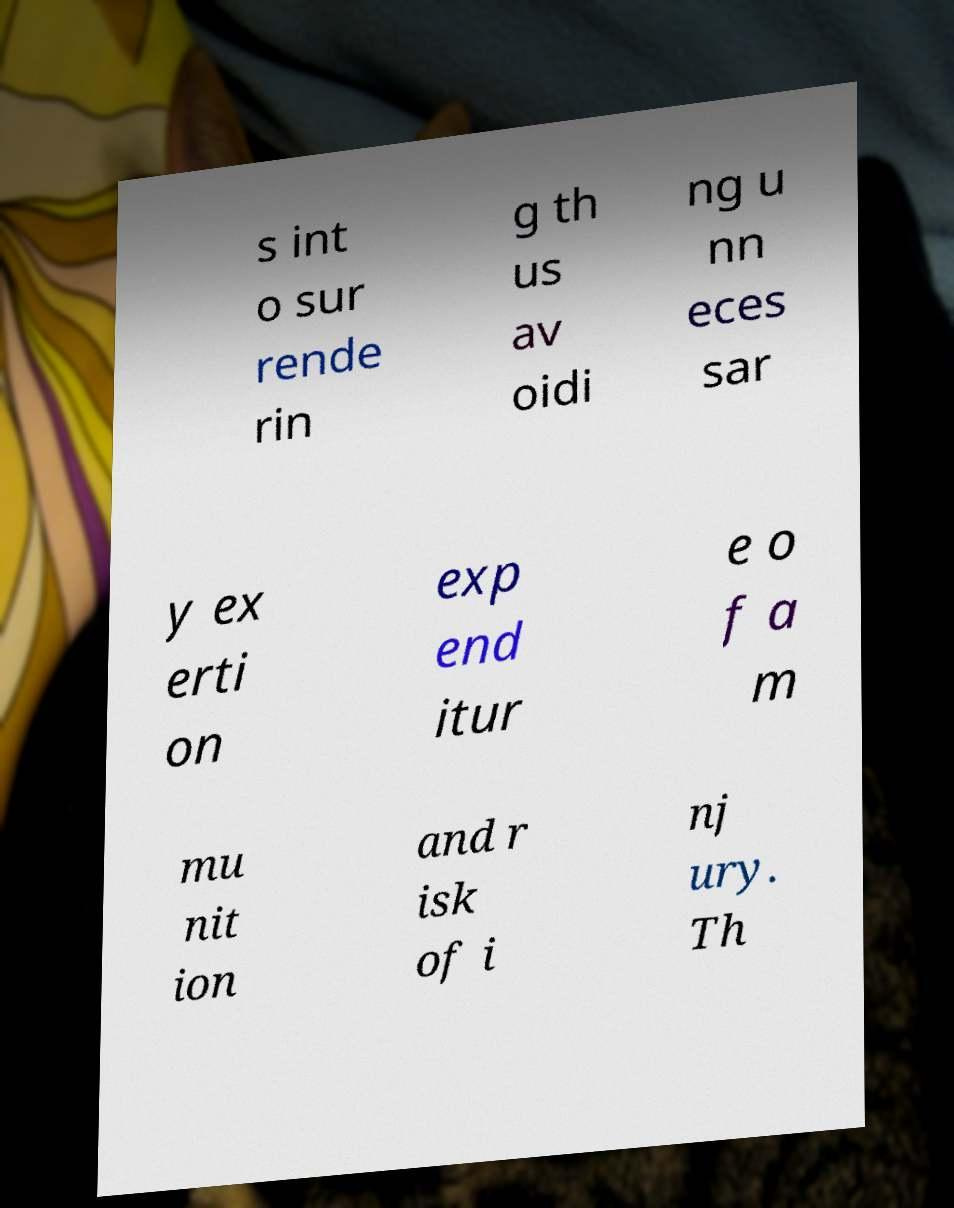For documentation purposes, I need the text within this image transcribed. Could you provide that? s int o sur rende rin g th us av oidi ng u nn eces sar y ex erti on exp end itur e o f a m mu nit ion and r isk of i nj ury. Th 